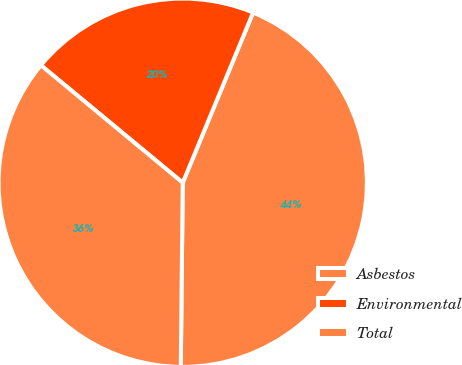Convert chart to OTSL. <chart><loc_0><loc_0><loc_500><loc_500><pie_chart><fcel>Asbestos<fcel>Environmental<fcel>Total<nl><fcel>43.93%<fcel>20.23%<fcel>35.84%<nl></chart> 